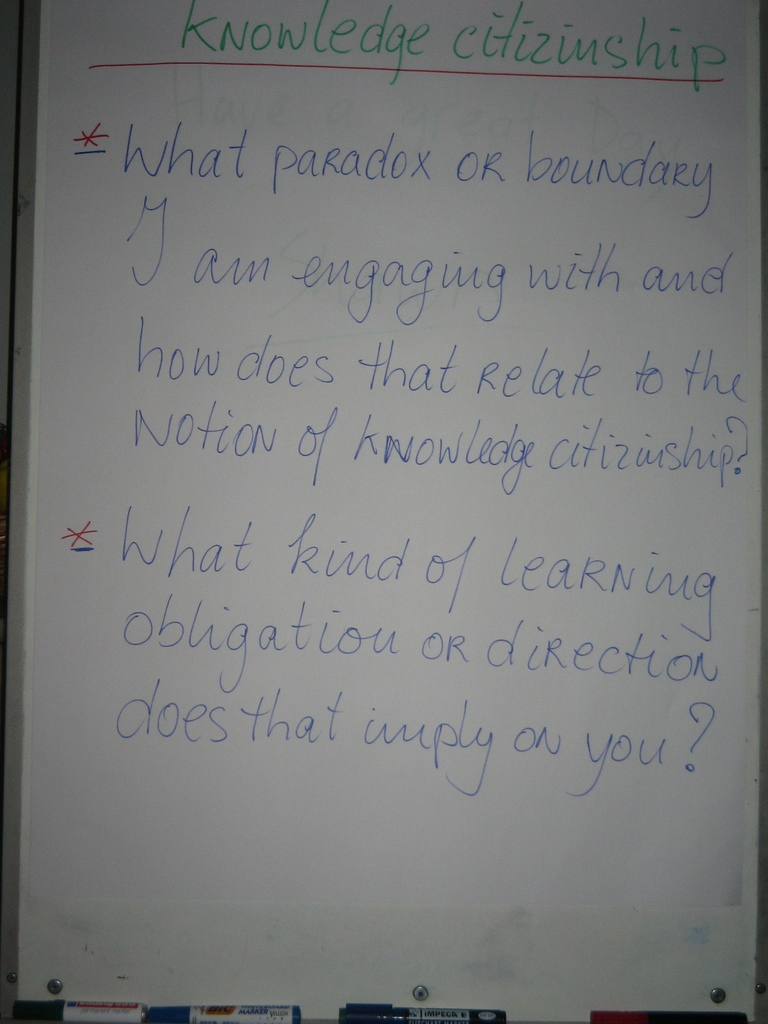Can you explain what 'knowledge citizenship' might entail in a classroom setting? In a classroom setting, 'knowledge citizenship' could refer to the active participation and collaboration of students and educators in creating a shared learning environment. It involves not only absorbing information but contributing ideas, raising questions, and critically engaging with content. It emphasizes the importance of every member taking responsibility for both teaching and learning, fostering a culture of mutual respect and intellectual curiosity. 